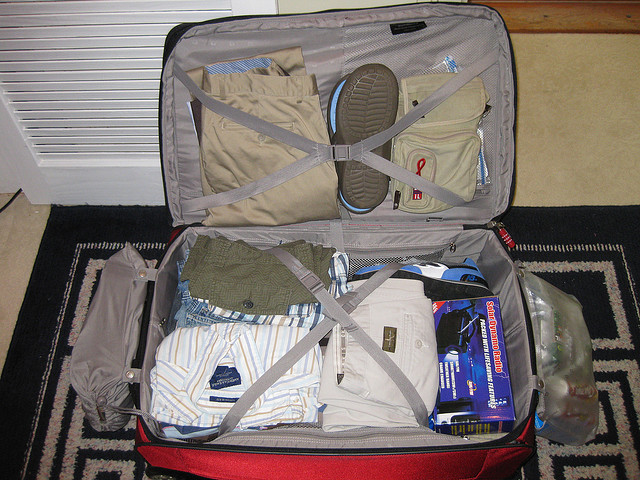Identify the text displayed in this image. Soln 